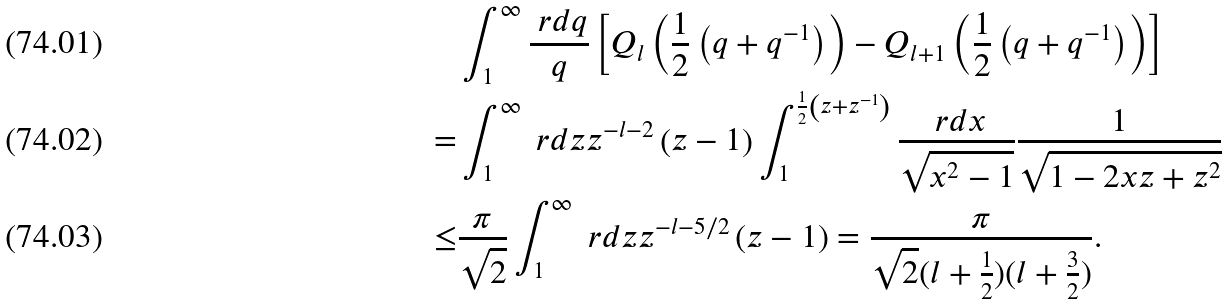<formula> <loc_0><loc_0><loc_500><loc_500>& \int _ { 1 } ^ { \infty } \frac { \ r d q } { q } \left [ Q _ { l } \left ( \frac { 1 } { 2 } \left ( q + q ^ { - 1 } \right ) \right ) - Q _ { l + 1 } \left ( \frac { 1 } { 2 } \left ( q + q ^ { - 1 } \right ) \right ) \right ] \\ = & \int _ { 1 } ^ { \infty } \ r d z z ^ { - l - 2 } \left ( z - 1 \right ) \int _ { 1 } ^ { \frac { 1 } { 2 } \left ( z + z ^ { - 1 } \right ) } \frac { \ r d x } { \sqrt { x ^ { 2 } - 1 } } \frac { 1 } { \sqrt { 1 - 2 x z + z ^ { 2 } } } \\ \leq & \frac { \pi } { \sqrt { 2 } } \int _ { 1 } ^ { \infty } \ r d z z ^ { - l - 5 / 2 } \left ( z - 1 \right ) = \frac { \pi } { \sqrt { 2 } ( l + \frac { 1 } { 2 } ) ( l + \frac { 3 } { 2 } ) } .</formula> 